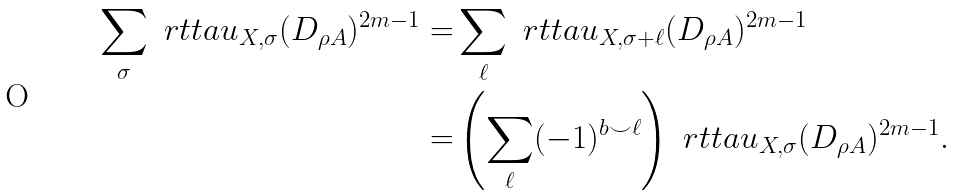<formula> <loc_0><loc_0><loc_500><loc_500>\sum _ { \sigma } \ r t t a u _ { X , \sigma } ( D _ { \rho A } ) ^ { 2 m - 1 } = & \sum _ { \ell } \ r t t a u _ { X , \sigma + \ell } ( D _ { \rho A } ) ^ { 2 m - 1 } \\ = & \left ( \sum _ { \ell } ( - 1 ) ^ { b \smile \ell } \right ) \ r t t a u _ { X , \sigma } ( D _ { \rho A } ) ^ { 2 m - 1 } .</formula> 